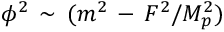<formula> <loc_0><loc_0><loc_500><loc_500>\phi ^ { 2 } \, \sim \, ( m ^ { 2 } \, - \, F ^ { 2 } / M _ { p } ^ { 2 } )</formula> 